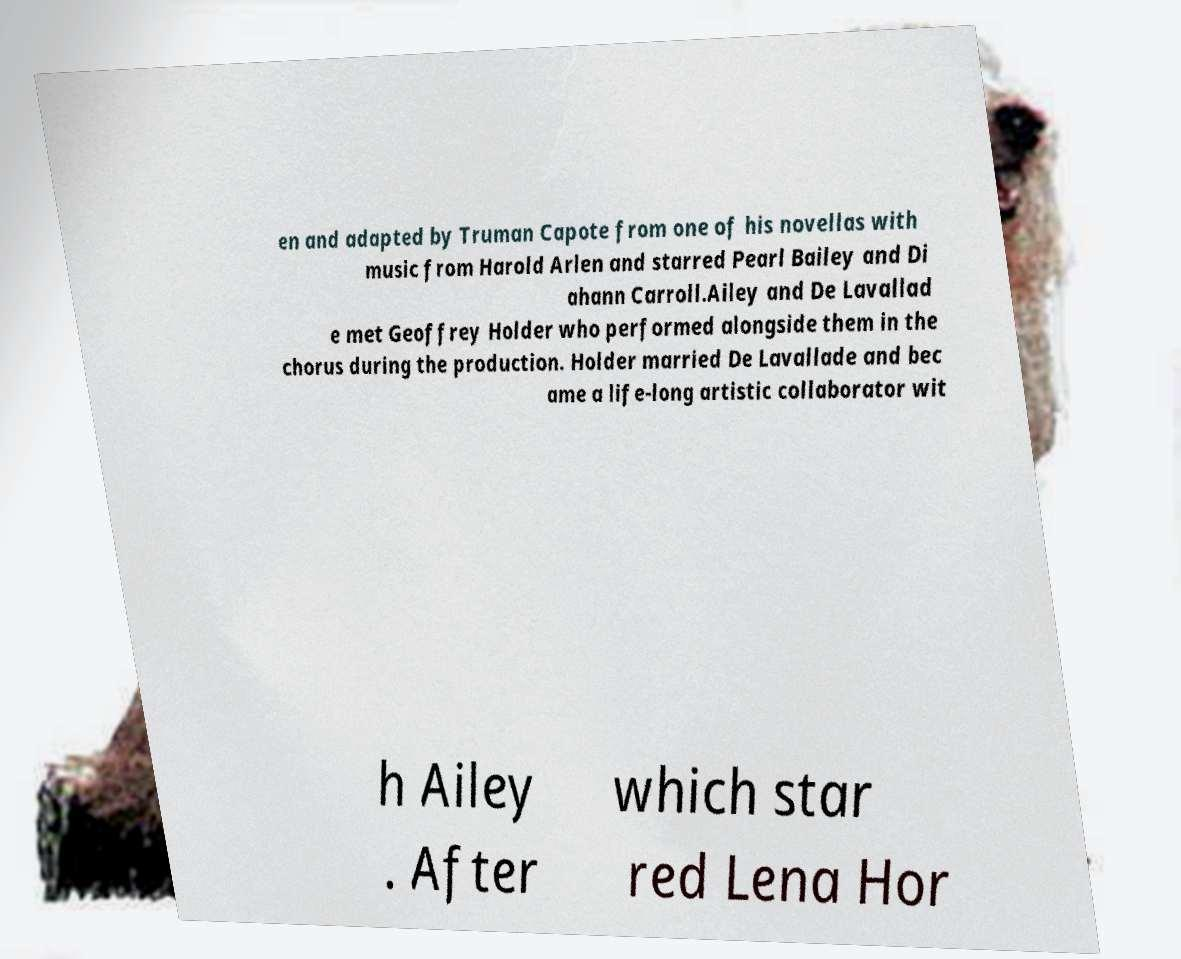There's text embedded in this image that I need extracted. Can you transcribe it verbatim? en and adapted by Truman Capote from one of his novellas with music from Harold Arlen and starred Pearl Bailey and Di ahann Carroll.Ailey and De Lavallad e met Geoffrey Holder who performed alongside them in the chorus during the production. Holder married De Lavallade and bec ame a life-long artistic collaborator wit h Ailey . After which star red Lena Hor 